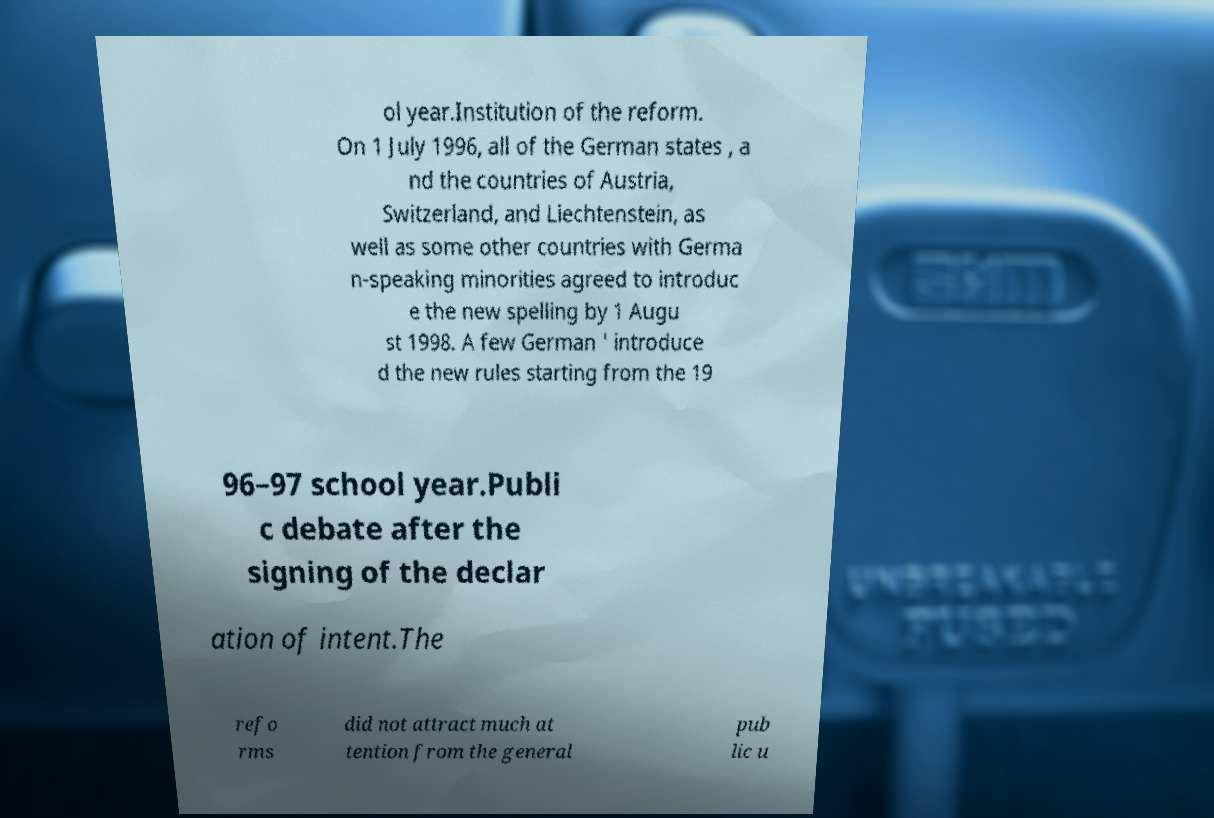I need the written content from this picture converted into text. Can you do that? ol year.Institution of the reform. On 1 July 1996, all of the German states , a nd the countries of Austria, Switzerland, and Liechtenstein, as well as some other countries with Germa n-speaking minorities agreed to introduc e the new spelling by 1 Augu st 1998. A few German ' introduce d the new rules starting from the 19 96–97 school year.Publi c debate after the signing of the declar ation of intent.The refo rms did not attract much at tention from the general pub lic u 